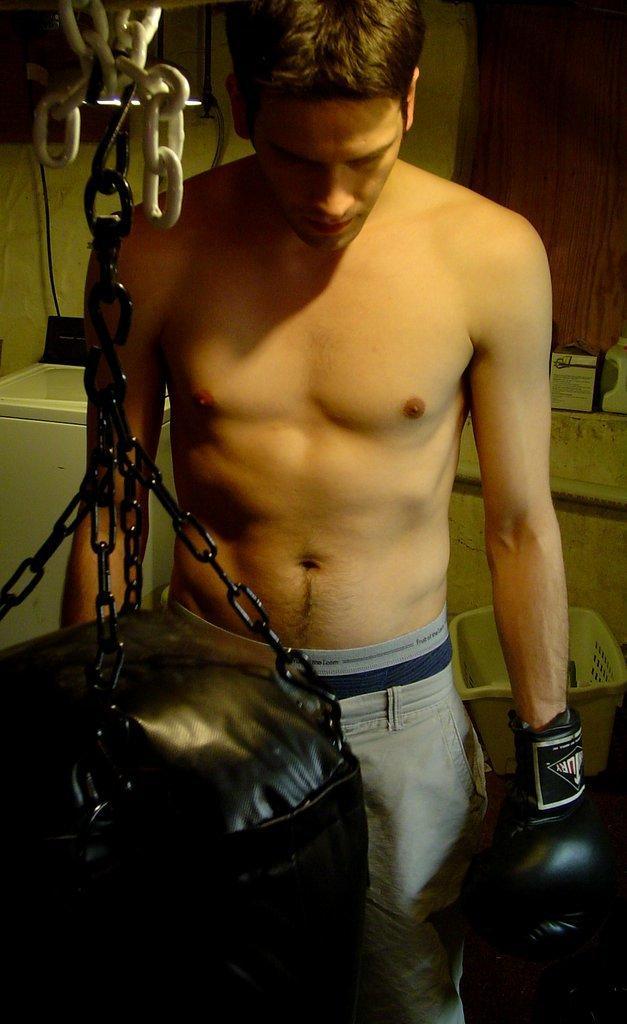In one or two sentences, can you explain what this image depicts? In this image I can see a punching bag which is black in color is tied to the metal rod which is tied to the metal rod with a black colored metal chain. I can see a person wearing grey color pant and black colored gloves is standing. In the background I can see the wall, a plastic basket, the curtain and few other objects. 